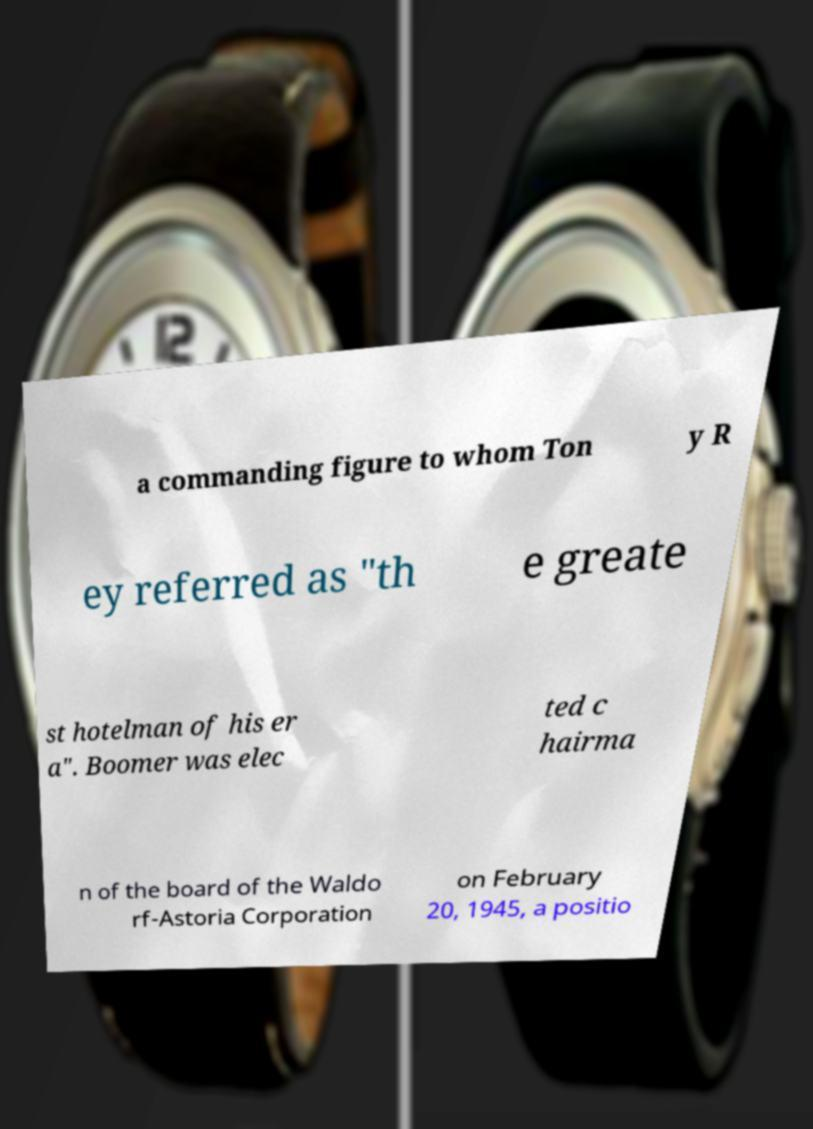Please identify and transcribe the text found in this image. a commanding figure to whom Ton y R ey referred as "th e greate st hotelman of his er a". Boomer was elec ted c hairma n of the board of the Waldo rf-Astoria Corporation on February 20, 1945, a positio 